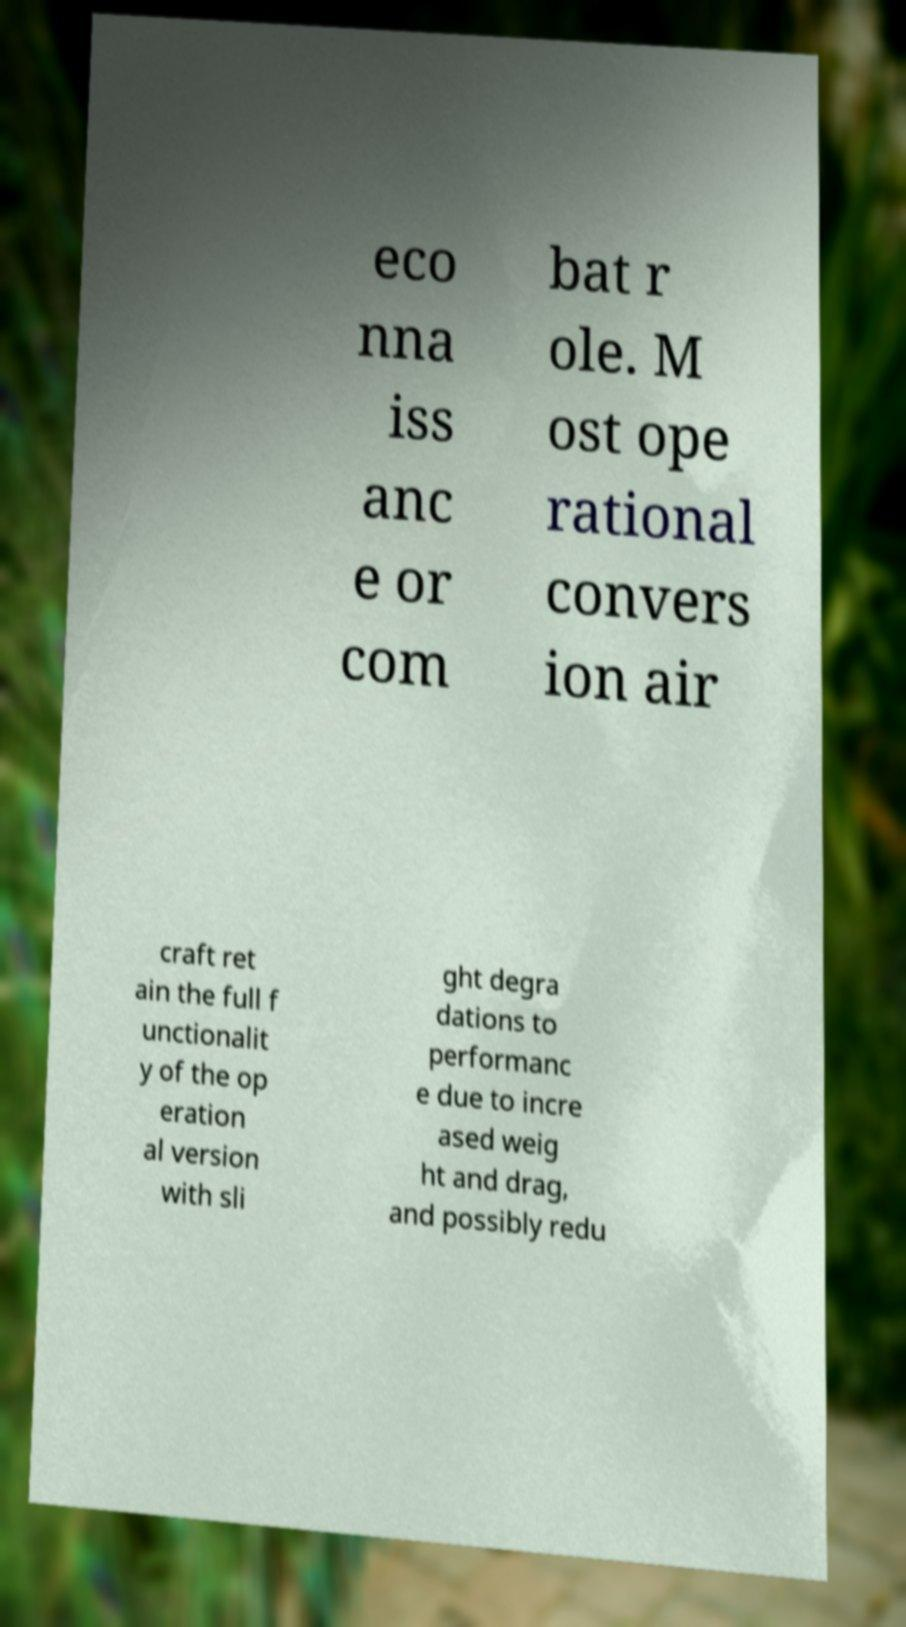Could you assist in decoding the text presented in this image and type it out clearly? eco nna iss anc e or com bat r ole. M ost ope rational convers ion air craft ret ain the full f unctionalit y of the op eration al version with sli ght degra dations to performanc e due to incre ased weig ht and drag, and possibly redu 